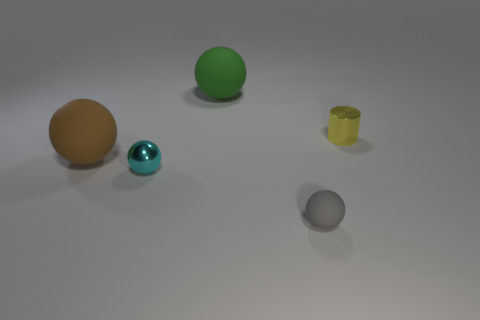Is the number of yellow things behind the cylinder the same as the number of small yellow objects that are on the left side of the large green matte thing?
Keep it short and to the point. Yes. There is a yellow object; is it the same shape as the matte thing that is behind the brown object?
Your answer should be very brief. No. Is there anything else that is the same shape as the small cyan object?
Provide a short and direct response. Yes. Is the big brown ball made of the same material as the object behind the yellow cylinder?
Offer a terse response. Yes. What is the color of the large ball to the right of the big thing in front of the big green matte thing that is to the left of the small gray thing?
Provide a short and direct response. Green. Do the cylinder and the small ball to the left of the gray matte sphere have the same color?
Make the answer very short. No. What is the color of the tiny matte sphere?
Provide a succinct answer. Gray. What is the shape of the small thing in front of the metal thing left of the large rubber thing that is behind the brown rubber sphere?
Make the answer very short. Sphere. What number of other objects are there of the same color as the small cylinder?
Keep it short and to the point. 0. Is the number of metallic spheres to the right of the tiny cyan ball greater than the number of small metal cylinders that are in front of the tiny gray rubber object?
Offer a terse response. No. 